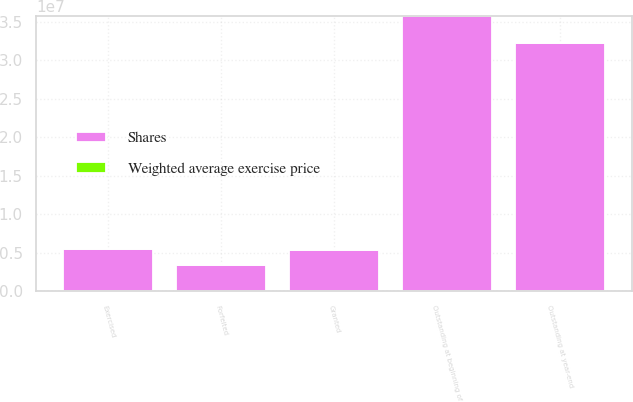Convert chart to OTSL. <chart><loc_0><loc_0><loc_500><loc_500><stacked_bar_chart><ecel><fcel>Outstanding at beginning of<fcel>Granted<fcel>Exercised<fcel>Forfeited<fcel>Outstanding at year-end<nl><fcel>Shares<fcel>3.57188e+07<fcel>5.4219e+06<fcel>5.44355e+06<fcel>3.39581e+06<fcel>3.23013e+07<nl><fcel>Weighted average exercise price<fcel>41.02<fcel>84.95<fcel>32.69<fcel>42.68<fcel>50.36<nl></chart> 